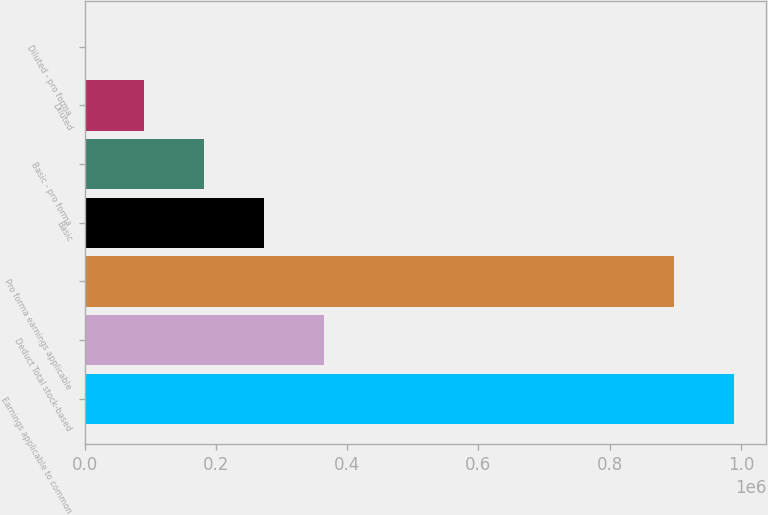<chart> <loc_0><loc_0><loc_500><loc_500><bar_chart><fcel>Earnings applicable to common<fcel>Deduct Total stock-based<fcel>Pro forma earnings applicable<fcel>Basic<fcel>Basic - pro forma<fcel>Diluted<fcel>Diluted - pro forma<nl><fcel>988949<fcel>363812<fcel>897997<fcel>272860<fcel>181908<fcel>90955.9<fcel>3.88<nl></chart> 